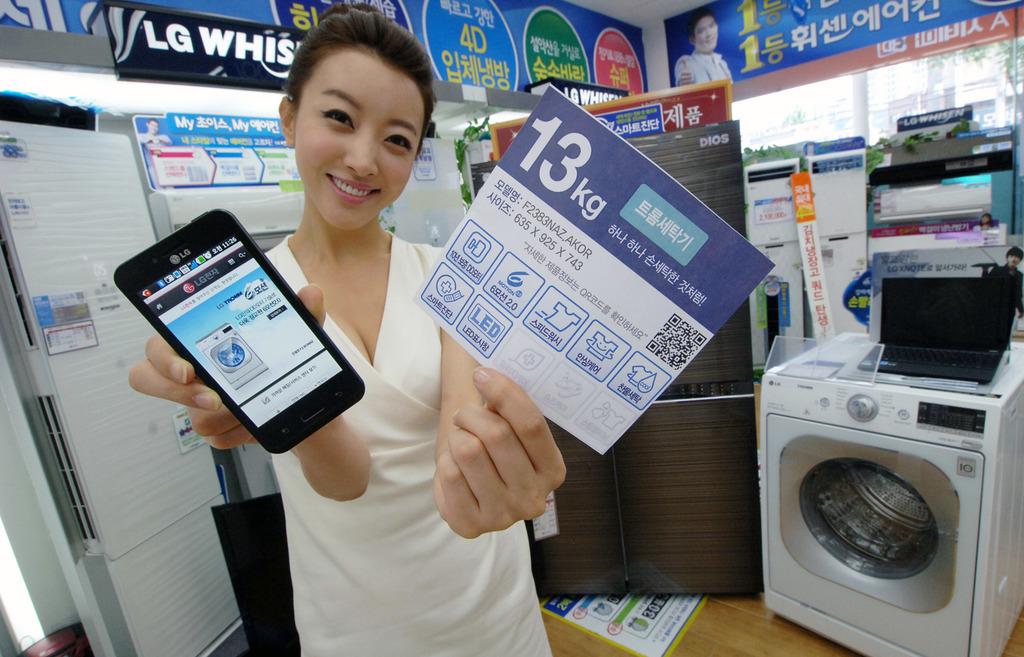How many kilograms does the box say it weighs?
Offer a terse response. 13. What is the name of the brand?
Keep it short and to the point. Lg. 